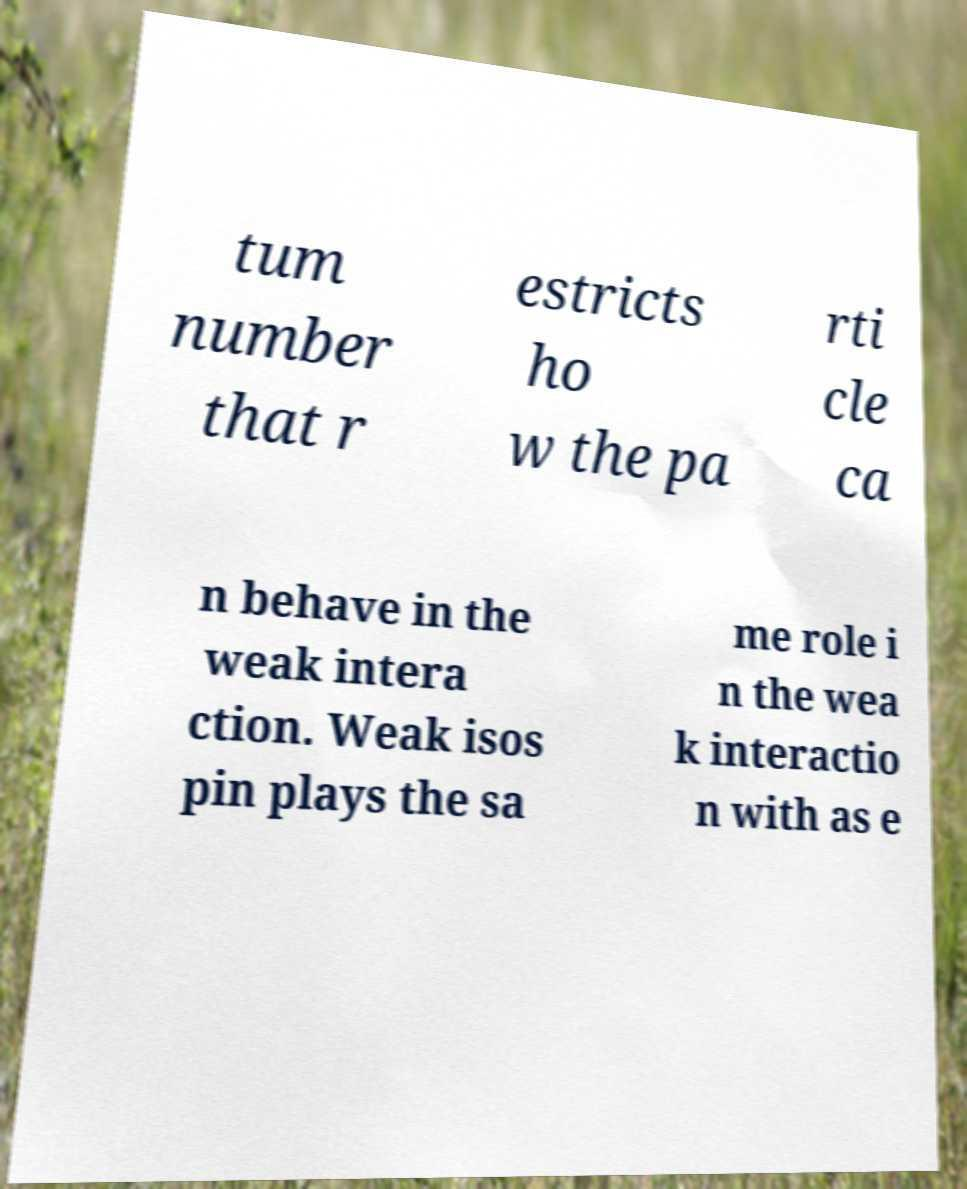Could you assist in decoding the text presented in this image and type it out clearly? tum number that r estricts ho w the pa rti cle ca n behave in the weak intera ction. Weak isos pin plays the sa me role i n the wea k interactio n with as e 